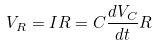<formula> <loc_0><loc_0><loc_500><loc_500>V _ { R } = I R = C \frac { d V _ { C } } { d t } R</formula> 